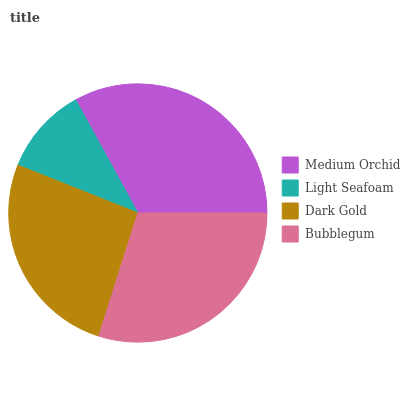Is Light Seafoam the minimum?
Answer yes or no. Yes. Is Medium Orchid the maximum?
Answer yes or no. Yes. Is Dark Gold the minimum?
Answer yes or no. No. Is Dark Gold the maximum?
Answer yes or no. No. Is Dark Gold greater than Light Seafoam?
Answer yes or no. Yes. Is Light Seafoam less than Dark Gold?
Answer yes or no. Yes. Is Light Seafoam greater than Dark Gold?
Answer yes or no. No. Is Dark Gold less than Light Seafoam?
Answer yes or no. No. Is Bubblegum the high median?
Answer yes or no. Yes. Is Dark Gold the low median?
Answer yes or no. Yes. Is Light Seafoam the high median?
Answer yes or no. No. Is Light Seafoam the low median?
Answer yes or no. No. 